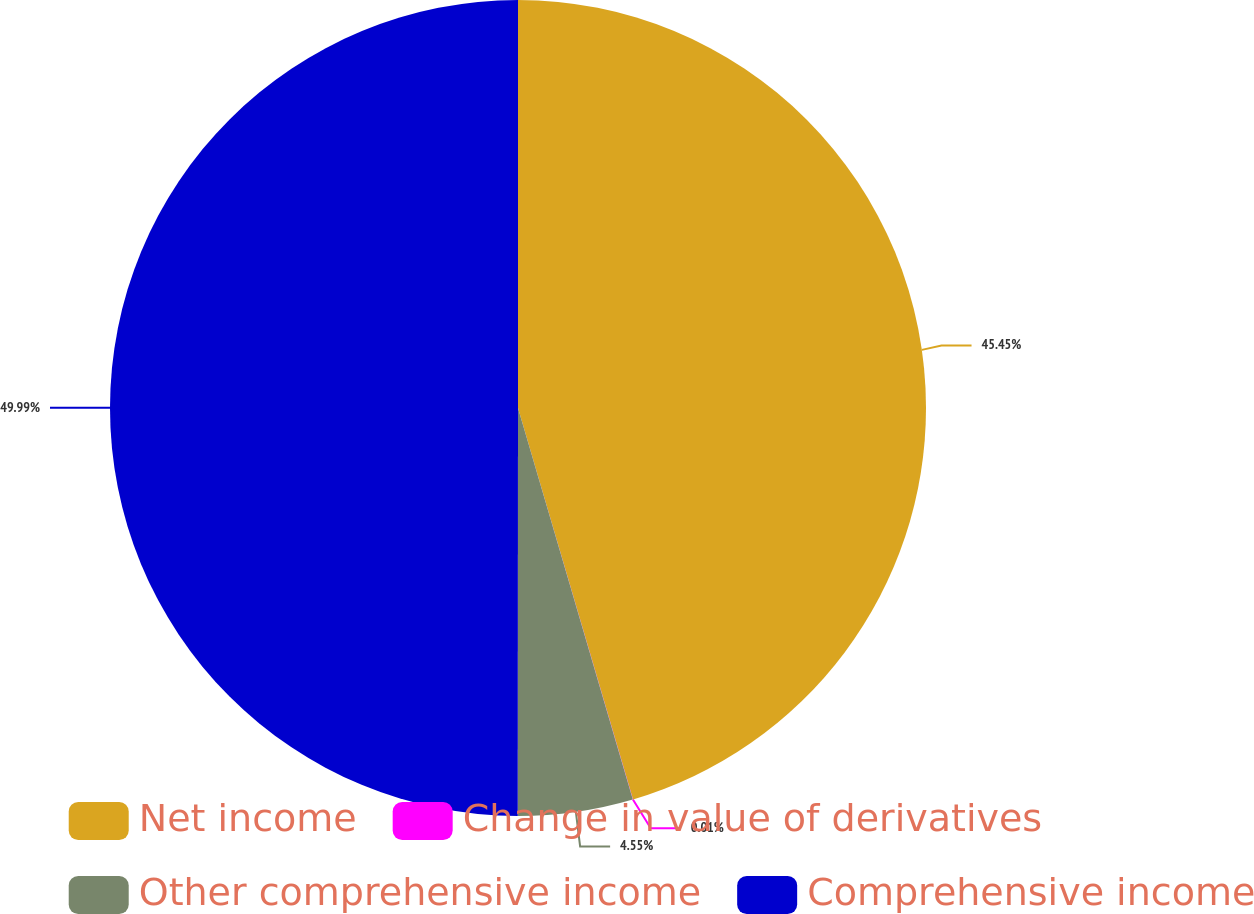Convert chart. <chart><loc_0><loc_0><loc_500><loc_500><pie_chart><fcel>Net income<fcel>Change in value of derivatives<fcel>Other comprehensive income<fcel>Comprehensive income<nl><fcel>45.45%<fcel>0.01%<fcel>4.55%<fcel>49.99%<nl></chart> 